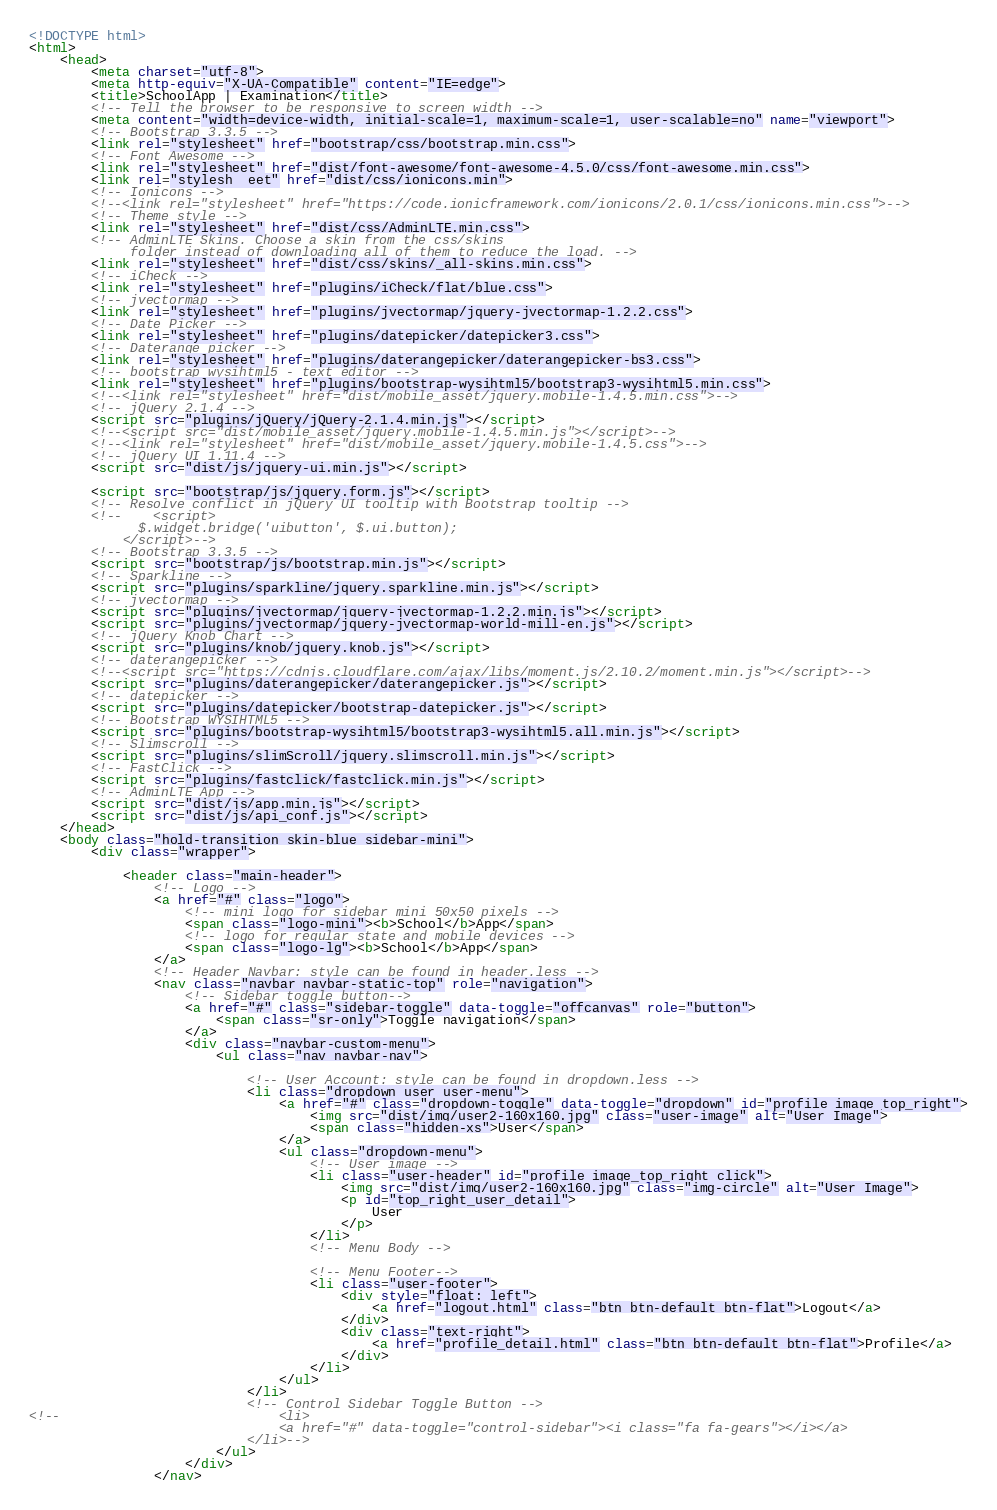<code> <loc_0><loc_0><loc_500><loc_500><_HTML_><!DOCTYPE html>
<html>
    <head>
        <meta charset="utf-8">
        <meta http-equiv="X-UA-Compatible" content="IE=edge">
        <title>SchoolApp | Examination</title>
        <!-- Tell the browser to be responsive to screen width -->
        <meta content="width=device-width, initial-scale=1, maximum-scale=1, user-scalable=no" name="viewport">
        <!-- Bootstrap 3.3.5 -->
        <link rel="stylesheet" href="bootstrap/css/bootstrap.min.css">
        <!-- Font Awesome -->
        <link rel="stylesheet" href="dist/font-awesome/font-awesome-4.5.0/css/font-awesome.min.css">
        <link rel="stylesh  eet" href="dist/css/ionicons.min">
        <!-- Ionicons -->
        <!--<link rel="stylesheet" href="https://code.ionicframework.com/ionicons/2.0.1/css/ionicons.min.css">-->
        <!-- Theme style -->
        <link rel="stylesheet" href="dist/css/AdminLTE.min.css">
        <!-- AdminLTE Skins. Choose a skin from the css/skins
             folder instead of downloading all of them to reduce the load. -->
        <link rel="stylesheet" href="dist/css/skins/_all-skins.min.css">
        <!-- iCheck -->
        <link rel="stylesheet" href="plugins/iCheck/flat/blue.css">
        <!-- jvectormap -->
        <link rel="stylesheet" href="plugins/jvectormap/jquery-jvectormap-1.2.2.css">
        <!-- Date Picker -->
        <link rel="stylesheet" href="plugins/datepicker/datepicker3.css">
        <!-- Daterange picker -->
        <link rel="stylesheet" href="plugins/daterangepicker/daterangepicker-bs3.css">
        <!-- bootstrap wysihtml5 - text editor -->
        <link rel="stylesheet" href="plugins/bootstrap-wysihtml5/bootstrap3-wysihtml5.min.css">
        <!--<link rel="stylesheet" href="dist/mobile_asset/jquery.mobile-1.4.5.min.css">-->
        <!-- jQuery 2.1.4 -->
        <script src="plugins/jQuery/jQuery-2.1.4.min.js"></script>
        <!--<script src="dist/mobile_asset/jquery.mobile-1.4.5.min.js"></script>-->
        <!--<link rel="stylesheet" href="dist/mobile_asset/jquery.mobile-1.4.5.css">-->
        <!-- jQuery UI 1.11.4 -->
        <script src="dist/js/jquery-ui.min.js"></script>

        <script src="bootstrap/js/jquery.form.js"></script>
        <!-- Resolve conflict in jQuery UI tooltip with Bootstrap tooltip -->
        <!--    <script>
              $.widget.bridge('uibutton', $.ui.button);
            </script>-->
        <!-- Bootstrap 3.3.5 -->
        <script src="bootstrap/js/bootstrap.min.js"></script>
        <!-- Sparkline -->
        <script src="plugins/sparkline/jquery.sparkline.min.js"></script>
        <!-- jvectormap -->
        <script src="plugins/jvectormap/jquery-jvectormap-1.2.2.min.js"></script>
        <script src="plugins/jvectormap/jquery-jvectormap-world-mill-en.js"></script>
        <!-- jQuery Knob Chart -->
        <script src="plugins/knob/jquery.knob.js"></script>
        <!-- daterangepicker -->
        <!--<script src="https://cdnjs.cloudflare.com/ajax/libs/moment.js/2.10.2/moment.min.js"></script>-->
        <script src="plugins/daterangepicker/daterangepicker.js"></script>
        <!-- datepicker -->
        <script src="plugins/datepicker/bootstrap-datepicker.js"></script>
        <!-- Bootstrap WYSIHTML5 -->
        <script src="plugins/bootstrap-wysihtml5/bootstrap3-wysihtml5.all.min.js"></script>
        <!-- Slimscroll -->
        <script src="plugins/slimScroll/jquery.slimscroll.min.js"></script>
        <!-- FastClick -->
        <script src="plugins/fastclick/fastclick.min.js"></script>
        <!-- AdminLTE App -->
        <script src="dist/js/app.min.js"></script>
        <script src="dist/js/api_conf.js"></script>
    </head>
    <body class="hold-transition skin-blue sidebar-mini">
        <div class="wrapper">

            <header class="main-header">
                <!-- Logo -->
                <a href="#" class="logo">
                    <!-- mini logo for sidebar mini 50x50 pixels -->
                    <span class="logo-mini"><b>School</b>App</span>
                    <!-- logo for regular state and mobile devices -->
                    <span class="logo-lg"><b>School</b>App</span>
                </a>
                <!-- Header Navbar: style can be found in header.less -->
                <nav class="navbar navbar-static-top" role="navigation">
                    <!-- Sidebar toggle button-->
                    <a href="#" class="sidebar-toggle" data-toggle="offcanvas" role="button">
                        <span class="sr-only">Toggle navigation</span>
                    </a>
                    <div class="navbar-custom-menu">
                        <ul class="nav navbar-nav">

                            <!-- User Account: style can be found in dropdown.less -->
                            <li class="dropdown user user-menu">
                                <a href="#" class="dropdown-toggle" data-toggle="dropdown" id="profile_image_top_right">
                                    <img src="dist/img/user2-160x160.jpg" class="user-image" alt="User Image">
                                    <span class="hidden-xs">User</span>
                                </a>
                                <ul class="dropdown-menu">
                                    <!-- User image -->
                                    <li class="user-header" id="profile_image_top_right_click">
                                        <img src="dist/img/user2-160x160.jpg" class="img-circle" alt="User Image">
                                        <p id="top_right_user_detail">
                                            User
                                        </p>
                                    </li>
                                    <!-- Menu Body -->

                                    <!-- Menu Footer-->
                                    <li class="user-footer">
                                        <div style="float: left">
                                            <a href="logout.html" class="btn btn-default btn-flat">Logout</a>
                                        </div>
                                        <div class="text-right">
                                            <a href="profile_detail.html" class="btn btn-default btn-flat">Profile</a>
                                        </div>
                                    </li>
                                </ul>
                            </li>
                            <!-- Control Sidebar Toggle Button -->
<!--                            <li>
                                <a href="#" data-toggle="control-sidebar"><i class="fa fa-gears"></i></a>
                            </li>-->
                        </ul>
                    </div>
                </nav></code> 